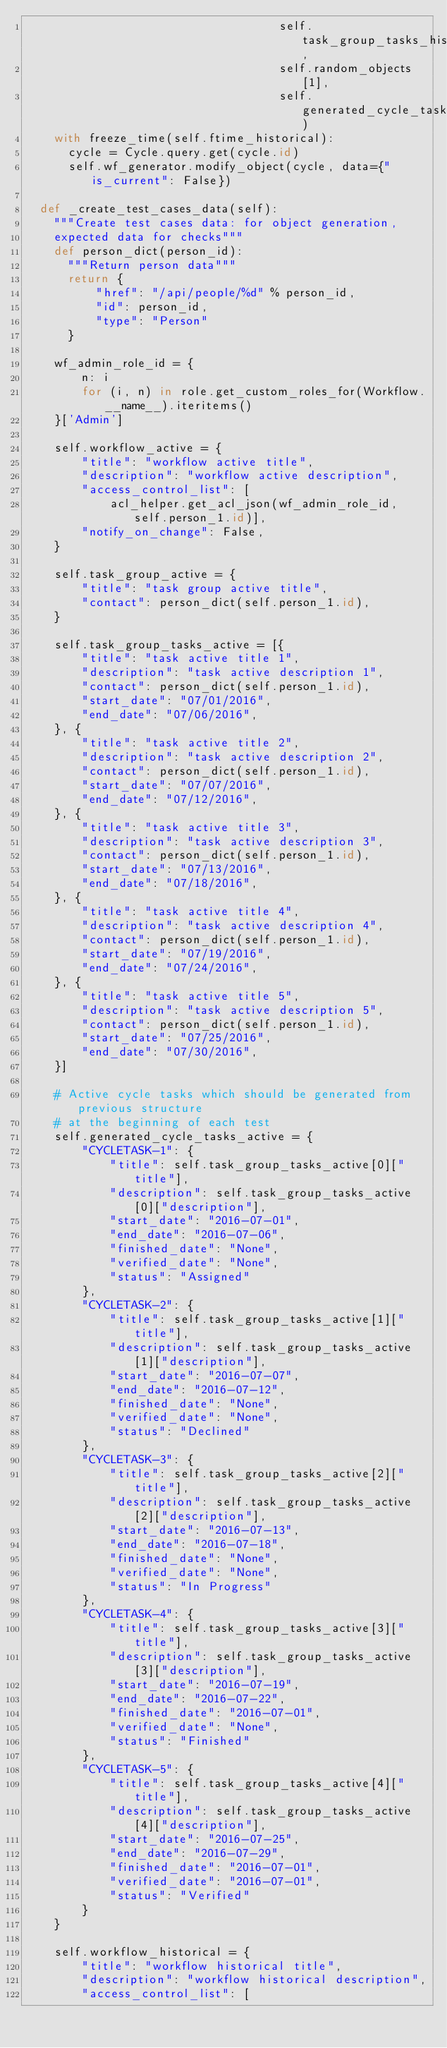Convert code to text. <code><loc_0><loc_0><loc_500><loc_500><_Python_>                                    self.task_group_tasks_historical,
                                    self.random_objects[1],
                                    self.generated_cycle_tasks_historical)
    with freeze_time(self.ftime_historical):
      cycle = Cycle.query.get(cycle.id)
      self.wf_generator.modify_object(cycle, data={"is_current": False})

  def _create_test_cases_data(self):
    """Create test cases data: for object generation,
    expected data for checks"""
    def person_dict(person_id):
      """Return person data"""
      return {
          "href": "/api/people/%d" % person_id,
          "id": person_id,
          "type": "Person"
      }

    wf_admin_role_id = {
        n: i
        for (i, n) in role.get_custom_roles_for(Workflow.__name__).iteritems()
    }['Admin']

    self.workflow_active = {
        "title": "workflow active title",
        "description": "workflow active description",
        "access_control_list": [
            acl_helper.get_acl_json(wf_admin_role_id, self.person_1.id)],
        "notify_on_change": False,
    }

    self.task_group_active = {
        "title": "task group active title",
        "contact": person_dict(self.person_1.id),
    }

    self.task_group_tasks_active = [{
        "title": "task active title 1",
        "description": "task active description 1",
        "contact": person_dict(self.person_1.id),
        "start_date": "07/01/2016",
        "end_date": "07/06/2016",
    }, {
        "title": "task active title 2",
        "description": "task active description 2",
        "contact": person_dict(self.person_1.id),
        "start_date": "07/07/2016",
        "end_date": "07/12/2016",
    }, {
        "title": "task active title 3",
        "description": "task active description 3",
        "contact": person_dict(self.person_1.id),
        "start_date": "07/13/2016",
        "end_date": "07/18/2016",
    }, {
        "title": "task active title 4",
        "description": "task active description 4",
        "contact": person_dict(self.person_1.id),
        "start_date": "07/19/2016",
        "end_date": "07/24/2016",
    }, {
        "title": "task active title 5",
        "description": "task active description 5",
        "contact": person_dict(self.person_1.id),
        "start_date": "07/25/2016",
        "end_date": "07/30/2016",
    }]

    # Active cycle tasks which should be generated from previous structure
    # at the beginning of each test
    self.generated_cycle_tasks_active = {
        "CYCLETASK-1": {
            "title": self.task_group_tasks_active[0]["title"],
            "description": self.task_group_tasks_active[0]["description"],
            "start_date": "2016-07-01",
            "end_date": "2016-07-06",
            "finished_date": "None",
            "verified_date": "None",
            "status": "Assigned"
        },
        "CYCLETASK-2": {
            "title": self.task_group_tasks_active[1]["title"],
            "description": self.task_group_tasks_active[1]["description"],
            "start_date": "2016-07-07",
            "end_date": "2016-07-12",
            "finished_date": "None",
            "verified_date": "None",
            "status": "Declined"
        },
        "CYCLETASK-3": {
            "title": self.task_group_tasks_active[2]["title"],
            "description": self.task_group_tasks_active[2]["description"],
            "start_date": "2016-07-13",
            "end_date": "2016-07-18",
            "finished_date": "None",
            "verified_date": "None",
            "status": "In Progress"
        },
        "CYCLETASK-4": {
            "title": self.task_group_tasks_active[3]["title"],
            "description": self.task_group_tasks_active[3]["description"],
            "start_date": "2016-07-19",
            "end_date": "2016-07-22",
            "finished_date": "2016-07-01",
            "verified_date": "None",
            "status": "Finished"
        },
        "CYCLETASK-5": {
            "title": self.task_group_tasks_active[4]["title"],
            "description": self.task_group_tasks_active[4]["description"],
            "start_date": "2016-07-25",
            "end_date": "2016-07-29",
            "finished_date": "2016-07-01",
            "verified_date": "2016-07-01",
            "status": "Verified"
        }
    }

    self.workflow_historical = {
        "title": "workflow historical title",
        "description": "workflow historical description",
        "access_control_list": [</code> 